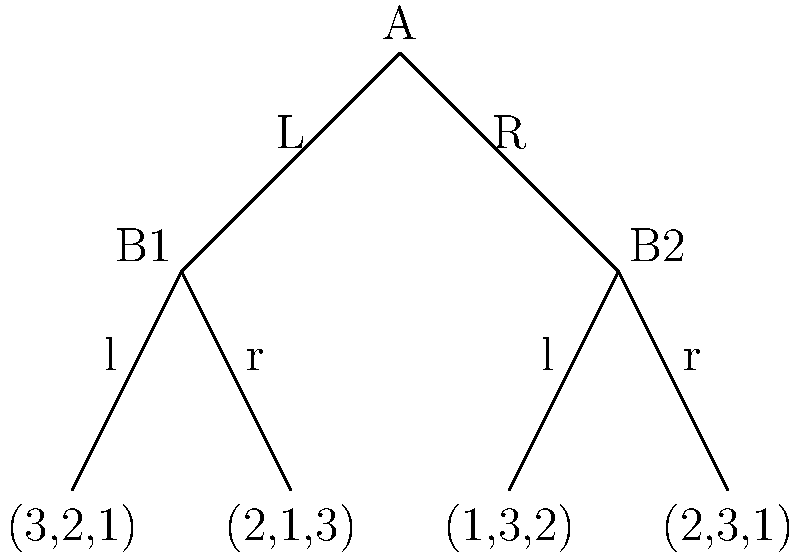Consider the three-player game represented by the decision tree above, where the payoffs are given in the order (Player 1, Player 2, Player 3). Assuming all players are rational and have perfect information, what is the Nash equilibrium of this game in terms of the strategies chosen by each player? To find the Nash equilibrium, we need to analyze the game using backward induction:

1. Start at the bottom of the tree and work upwards.

2. At B1:
   - If Player 2 chooses 'l', the payoff is (3,2,1)
   - If Player 2 chooses 'r', the payoff is (2,1,3)
   Player 2 will choose 'l' as it maximizes their payoff (2 > 1)

3. At B2:
   - If Player 2 chooses 'l', the payoff is (1,3,2)
   - If Player 2 chooses 'r', the payoff is (2,3,1)
   Player 2 will be indifferent between 'l' and 'r' as their payoff is the same (3)

4. At A:
   - If Player 1 chooses 'L', the payoff will be (3,2,1) based on Step 2
   - If Player 1 chooses 'R', the payoff will be either (1,3,2) or (2,3,1) based on Step 3
   Player 1 will choose 'L' as it maximizes their payoff (3 > 2 and 3 > 1)

5. Player 3 has no decisions to make, but their payoff is determined by the choices of Players 1 and 2.

Therefore, the Nash equilibrium strategies are:
- Player 1: Choose 'L'
- Player 2: Choose 'l' when at B1 (which will be reached in equilibrium)
- Player 3: No action (passive player)

This results in the payoff (3,2,1).
Answer: (L, l, -) 